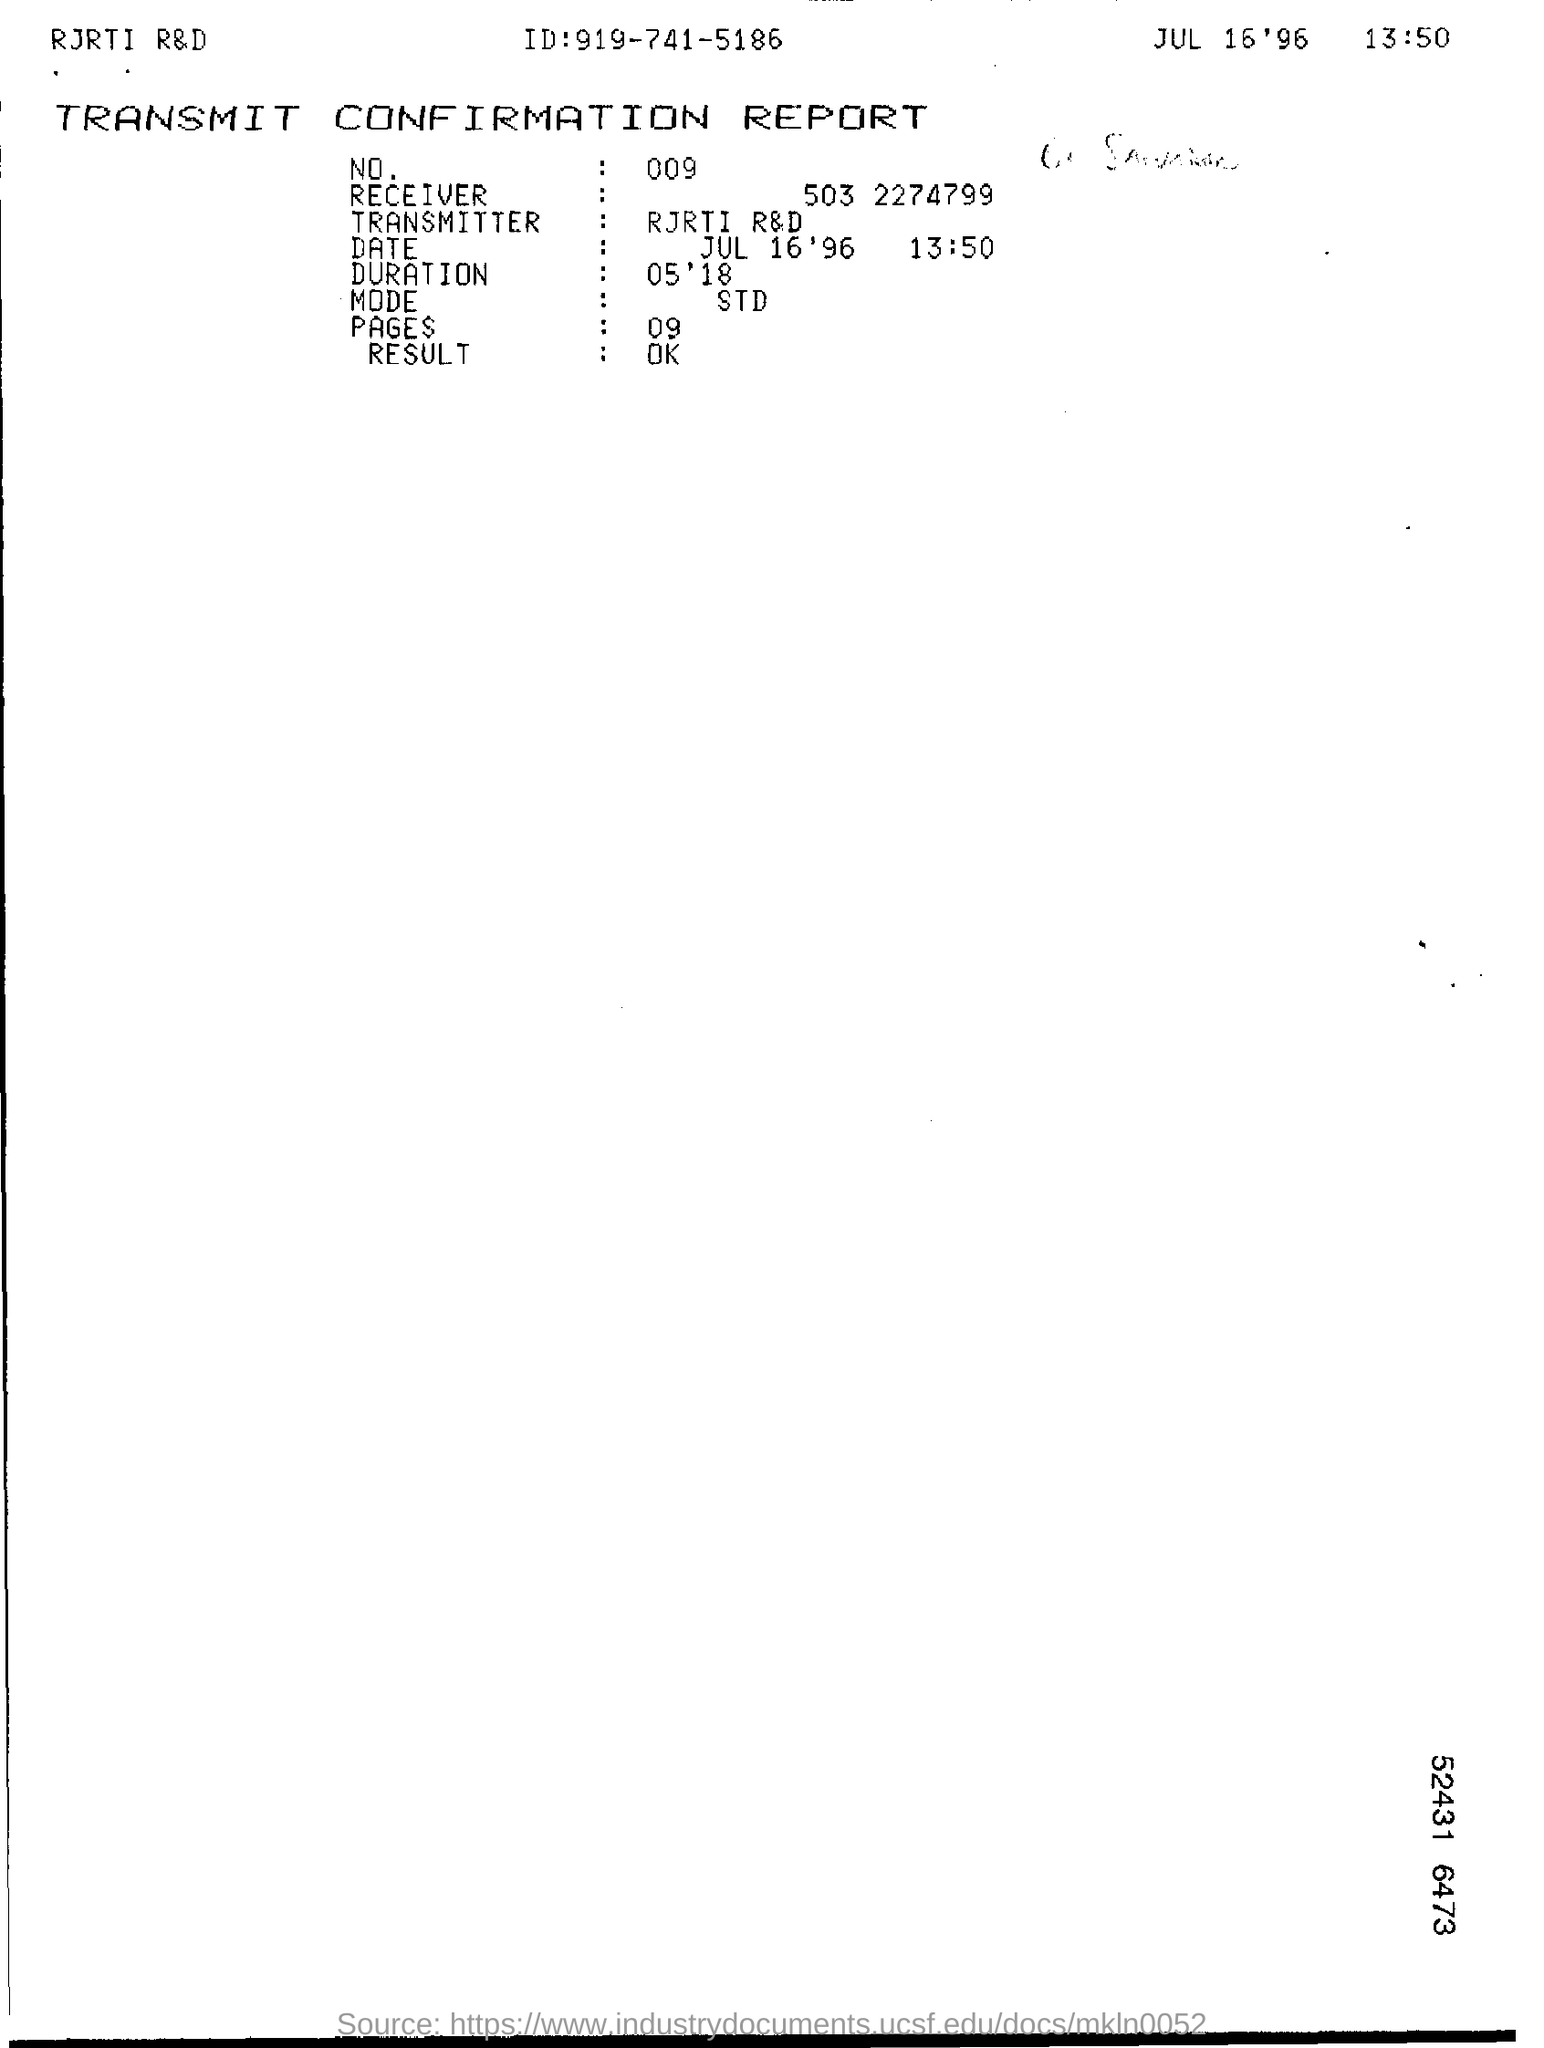Highlight a few significant elements in this photo. The duration as per the report is 05 ' 18. The report provides a phone number, which is 919-741-5186. The date mentioned in the transmit confirmation report is July 16, 1996 at 1:50 PM. The report mentions 09 pages. 